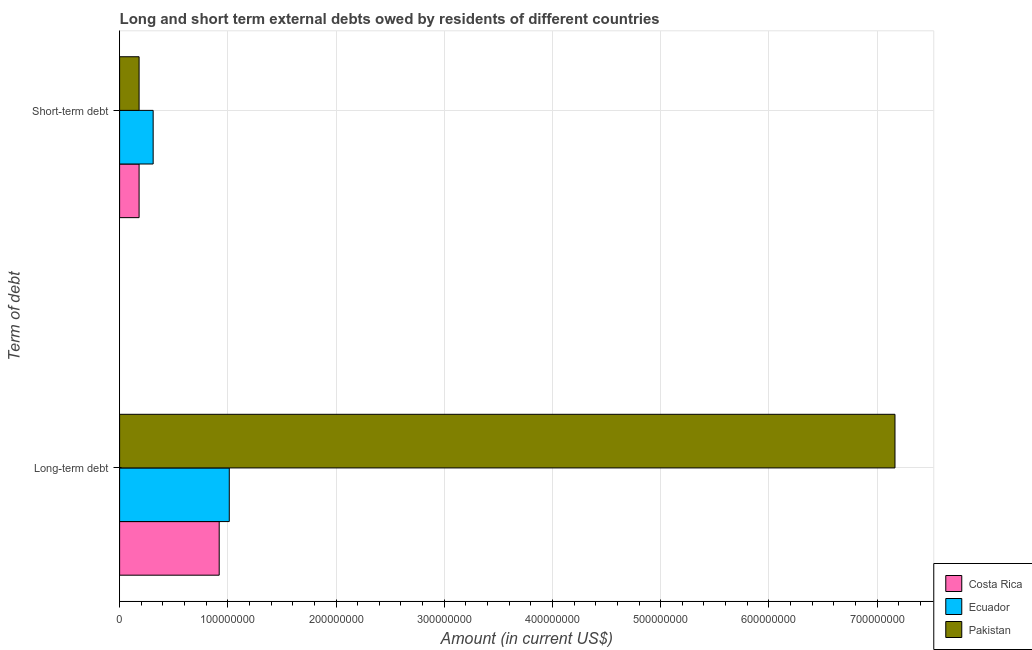How many different coloured bars are there?
Offer a terse response. 3. Are the number of bars per tick equal to the number of legend labels?
Provide a short and direct response. Yes. Are the number of bars on each tick of the Y-axis equal?
Offer a very short reply. Yes. How many bars are there on the 1st tick from the top?
Offer a terse response. 3. What is the label of the 1st group of bars from the top?
Give a very brief answer. Short-term debt. What is the long-term debts owed by residents in Pakistan?
Provide a succinct answer. 7.17e+08. Across all countries, what is the maximum short-term debts owed by residents?
Ensure brevity in your answer.  3.10e+07. Across all countries, what is the minimum short-term debts owed by residents?
Your answer should be very brief. 1.80e+07. In which country was the short-term debts owed by residents maximum?
Provide a short and direct response. Ecuador. What is the total long-term debts owed by residents in the graph?
Your response must be concise. 9.10e+08. What is the difference between the long-term debts owed by residents in Pakistan and that in Costa Rica?
Keep it short and to the point. 6.24e+08. What is the difference between the long-term debts owed by residents in Costa Rica and the short-term debts owed by residents in Pakistan?
Offer a terse response. 7.40e+07. What is the average long-term debts owed by residents per country?
Offer a very short reply. 3.03e+08. What is the difference between the short-term debts owed by residents and long-term debts owed by residents in Costa Rica?
Offer a very short reply. -7.40e+07. In how many countries, is the short-term debts owed by residents greater than 480000000 US$?
Provide a short and direct response. 0. What is the ratio of the short-term debts owed by residents in Costa Rica to that in Ecuador?
Your response must be concise. 0.58. In how many countries, is the short-term debts owed by residents greater than the average short-term debts owed by residents taken over all countries?
Your answer should be very brief. 1. What does the 2nd bar from the top in Short-term debt represents?
Provide a succinct answer. Ecuador. What does the 3rd bar from the bottom in Long-term debt represents?
Offer a very short reply. Pakistan. How many bars are there?
Your response must be concise. 6. Are all the bars in the graph horizontal?
Your answer should be compact. Yes. What is the difference between two consecutive major ticks on the X-axis?
Your answer should be compact. 1.00e+08. Are the values on the major ticks of X-axis written in scientific E-notation?
Make the answer very short. No. Does the graph contain any zero values?
Make the answer very short. No. Does the graph contain grids?
Make the answer very short. Yes. How many legend labels are there?
Offer a very short reply. 3. How are the legend labels stacked?
Give a very brief answer. Vertical. What is the title of the graph?
Keep it short and to the point. Long and short term external debts owed by residents of different countries. What is the label or title of the Y-axis?
Ensure brevity in your answer.  Term of debt. What is the Amount (in current US$) in Costa Rica in Long-term debt?
Provide a succinct answer. 9.20e+07. What is the Amount (in current US$) in Ecuador in Long-term debt?
Offer a terse response. 1.01e+08. What is the Amount (in current US$) of Pakistan in Long-term debt?
Offer a terse response. 7.17e+08. What is the Amount (in current US$) of Costa Rica in Short-term debt?
Provide a succinct answer. 1.80e+07. What is the Amount (in current US$) of Ecuador in Short-term debt?
Your answer should be compact. 3.10e+07. What is the Amount (in current US$) of Pakistan in Short-term debt?
Provide a short and direct response. 1.80e+07. Across all Term of debt, what is the maximum Amount (in current US$) in Costa Rica?
Your answer should be compact. 9.20e+07. Across all Term of debt, what is the maximum Amount (in current US$) of Ecuador?
Provide a short and direct response. 1.01e+08. Across all Term of debt, what is the maximum Amount (in current US$) in Pakistan?
Ensure brevity in your answer.  7.17e+08. Across all Term of debt, what is the minimum Amount (in current US$) in Costa Rica?
Offer a very short reply. 1.80e+07. Across all Term of debt, what is the minimum Amount (in current US$) of Ecuador?
Give a very brief answer. 3.10e+07. Across all Term of debt, what is the minimum Amount (in current US$) of Pakistan?
Your response must be concise. 1.80e+07. What is the total Amount (in current US$) of Costa Rica in the graph?
Keep it short and to the point. 1.10e+08. What is the total Amount (in current US$) in Ecuador in the graph?
Provide a short and direct response. 1.32e+08. What is the total Amount (in current US$) in Pakistan in the graph?
Provide a succinct answer. 7.35e+08. What is the difference between the Amount (in current US$) in Costa Rica in Long-term debt and that in Short-term debt?
Provide a short and direct response. 7.40e+07. What is the difference between the Amount (in current US$) in Ecuador in Long-term debt and that in Short-term debt?
Provide a succinct answer. 7.03e+07. What is the difference between the Amount (in current US$) in Pakistan in Long-term debt and that in Short-term debt?
Ensure brevity in your answer.  6.99e+08. What is the difference between the Amount (in current US$) in Costa Rica in Long-term debt and the Amount (in current US$) in Ecuador in Short-term debt?
Give a very brief answer. 6.10e+07. What is the difference between the Amount (in current US$) of Costa Rica in Long-term debt and the Amount (in current US$) of Pakistan in Short-term debt?
Your answer should be compact. 7.40e+07. What is the difference between the Amount (in current US$) of Ecuador in Long-term debt and the Amount (in current US$) of Pakistan in Short-term debt?
Your answer should be compact. 8.33e+07. What is the average Amount (in current US$) of Costa Rica per Term of debt?
Your response must be concise. 5.50e+07. What is the average Amount (in current US$) in Ecuador per Term of debt?
Your response must be concise. 6.62e+07. What is the average Amount (in current US$) of Pakistan per Term of debt?
Your response must be concise. 3.67e+08. What is the difference between the Amount (in current US$) of Costa Rica and Amount (in current US$) of Ecuador in Long-term debt?
Your response must be concise. -9.32e+06. What is the difference between the Amount (in current US$) of Costa Rica and Amount (in current US$) of Pakistan in Long-term debt?
Your answer should be very brief. -6.24e+08. What is the difference between the Amount (in current US$) of Ecuador and Amount (in current US$) of Pakistan in Long-term debt?
Provide a succinct answer. -6.15e+08. What is the difference between the Amount (in current US$) in Costa Rica and Amount (in current US$) in Ecuador in Short-term debt?
Make the answer very short. -1.30e+07. What is the difference between the Amount (in current US$) of Ecuador and Amount (in current US$) of Pakistan in Short-term debt?
Provide a short and direct response. 1.30e+07. What is the ratio of the Amount (in current US$) in Costa Rica in Long-term debt to that in Short-term debt?
Your response must be concise. 5.11. What is the ratio of the Amount (in current US$) of Ecuador in Long-term debt to that in Short-term debt?
Your answer should be very brief. 3.27. What is the ratio of the Amount (in current US$) of Pakistan in Long-term debt to that in Short-term debt?
Provide a succinct answer. 39.81. What is the difference between the highest and the second highest Amount (in current US$) of Costa Rica?
Ensure brevity in your answer.  7.40e+07. What is the difference between the highest and the second highest Amount (in current US$) in Ecuador?
Offer a very short reply. 7.03e+07. What is the difference between the highest and the second highest Amount (in current US$) in Pakistan?
Ensure brevity in your answer.  6.99e+08. What is the difference between the highest and the lowest Amount (in current US$) of Costa Rica?
Offer a terse response. 7.40e+07. What is the difference between the highest and the lowest Amount (in current US$) in Ecuador?
Offer a very short reply. 7.03e+07. What is the difference between the highest and the lowest Amount (in current US$) of Pakistan?
Keep it short and to the point. 6.99e+08. 